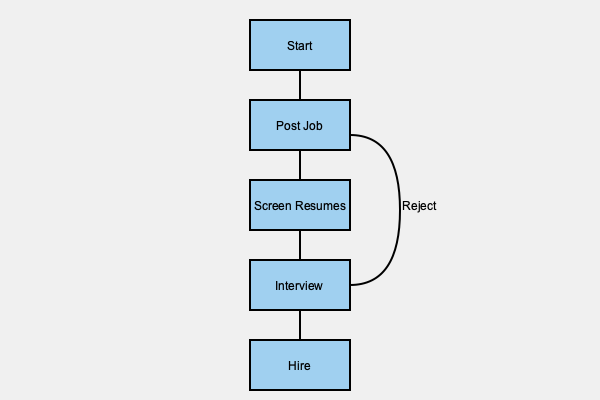In the hiring process flow chart for a new retail store, which step immediately follows the "Screen Resumes" stage? To answer this question, we need to analyze the flow chart of the hiring process for a new retail store. Let's break down the steps:

1. The process starts at the "Start" box at the top of the chart.
2. It then moves down to "Post Job", which is the first action in the hiring process.
3. The next step is "Screen Resumes", where the employer reviews the applications received.
4. Immediately following the "Screen Resumes" box, we see an arrow pointing down to the next step.
5. This arrow leads to the "Interview" box, indicating that interviewing candidates is the next step after screening resumes.
6. After the "Interview" step, there's a decision point where candidates can either be rejected (loop back to "Post Job") or move forward to the "Hire" step.

Therefore, based on the flow chart, the step that immediately follows "Screen Resumes" is the "Interview" stage.
Answer: Interview 